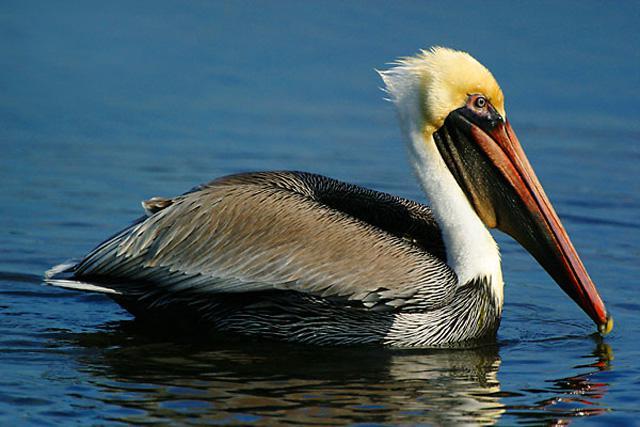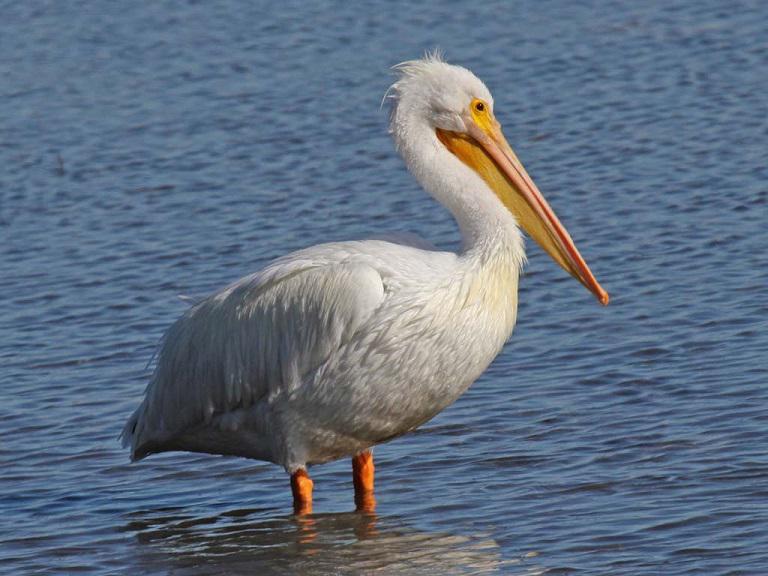The first image is the image on the left, the second image is the image on the right. For the images shown, is this caption "All of the birds are facing the right." true? Answer yes or no. Yes. 